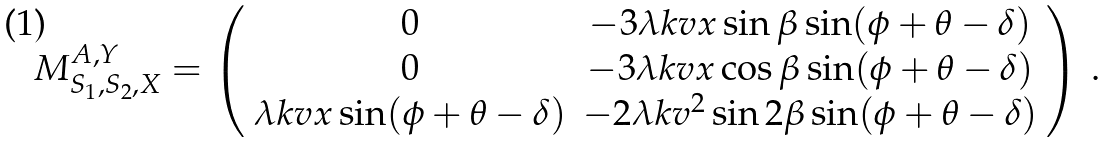<formula> <loc_0><loc_0><loc_500><loc_500>M _ { S _ { 1 } , S _ { 2 } , X } ^ { A , Y } = \left ( \begin{array} { c c } { 0 } & { - 3 \lambda k v x \sin \beta \sin ( \phi + \theta - \delta ) } \\ { 0 } & { - 3 \lambda k v x \cos \beta \sin ( \phi + \theta - \delta ) } \\ { \lambda k v x \sin ( \phi + \theta - \delta ) } & { { - 2 \lambda k v ^ { 2 } \sin 2 \beta \sin ( \phi + \theta - \delta ) } } \end{array} \right ) \, .</formula> 